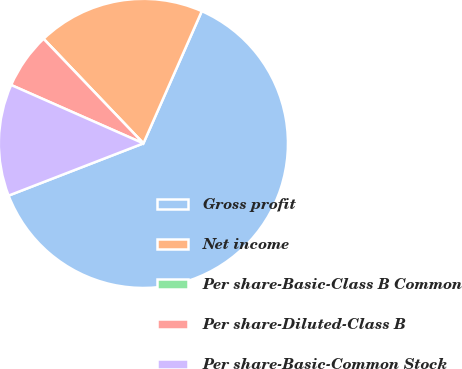Convert chart. <chart><loc_0><loc_0><loc_500><loc_500><pie_chart><fcel>Gross profit<fcel>Net income<fcel>Per share-Basic-Class B Common<fcel>Per share-Diluted-Class B<fcel>Per share-Basic-Common Stock<nl><fcel>62.5%<fcel>18.75%<fcel>0.0%<fcel>6.25%<fcel>12.5%<nl></chart> 